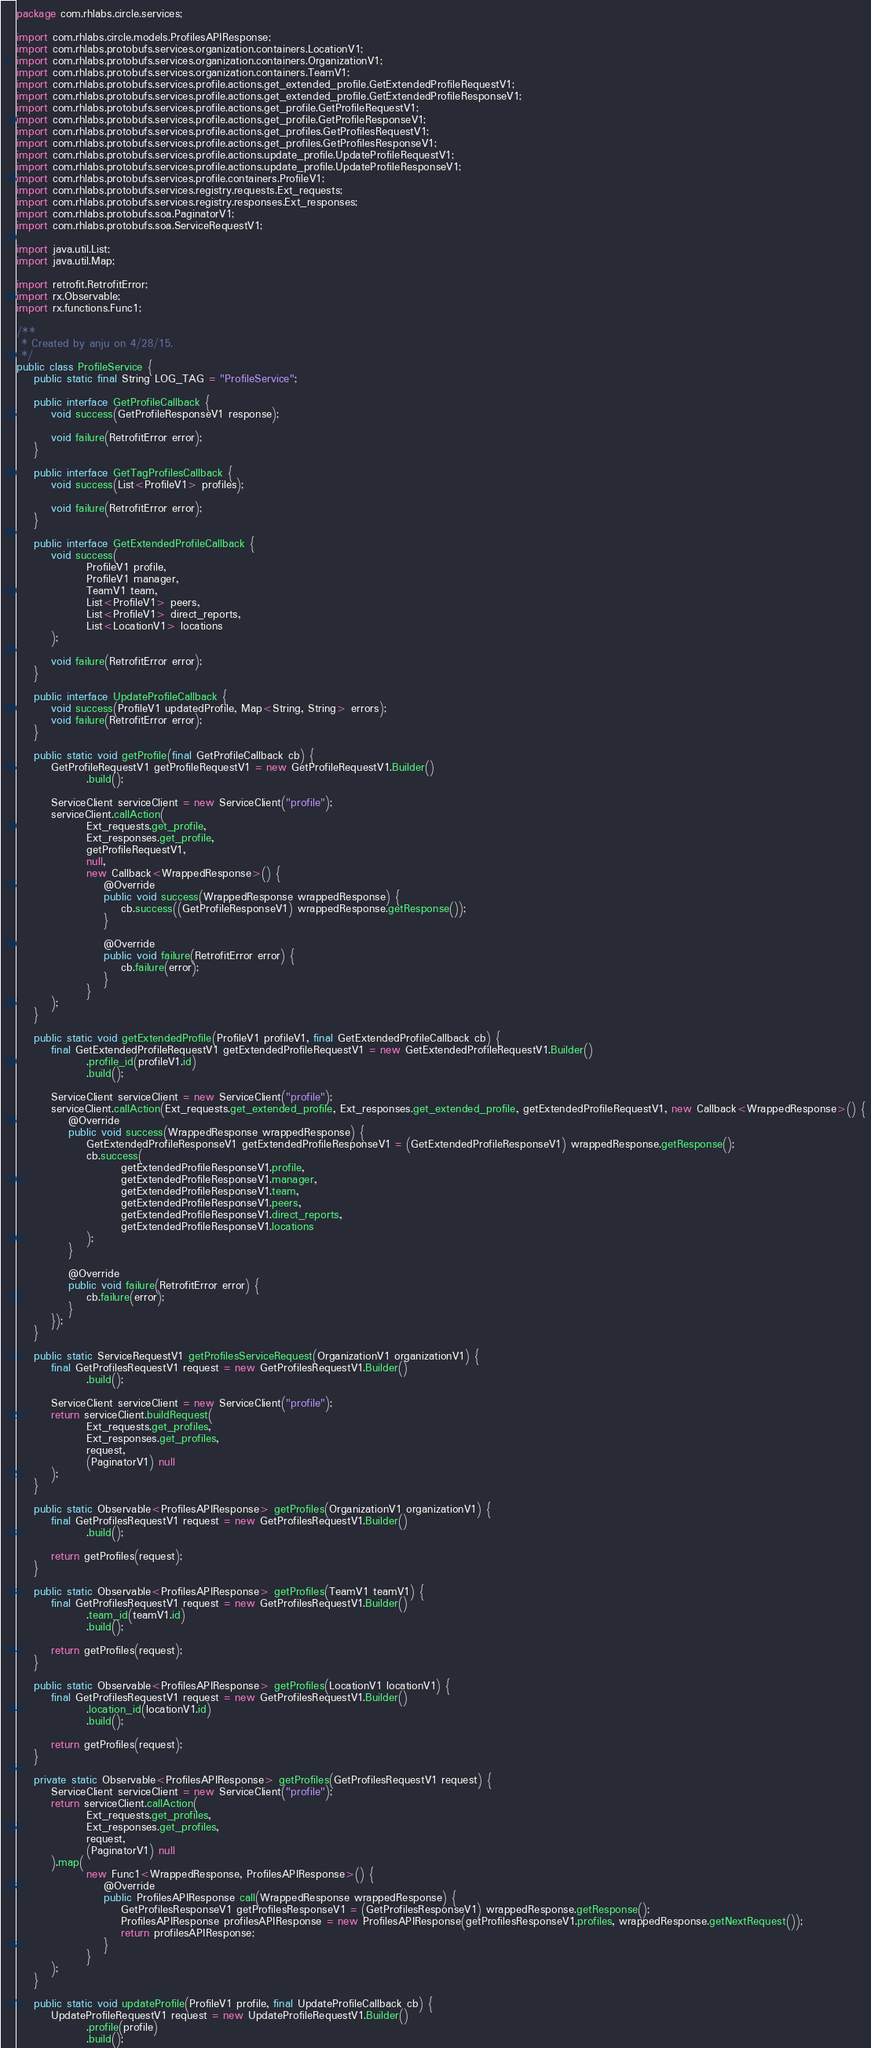<code> <loc_0><loc_0><loc_500><loc_500><_Java_>package com.rhlabs.circle.services;

import com.rhlabs.circle.models.ProfilesAPIResponse;
import com.rhlabs.protobufs.services.organization.containers.LocationV1;
import com.rhlabs.protobufs.services.organization.containers.OrganizationV1;
import com.rhlabs.protobufs.services.organization.containers.TeamV1;
import com.rhlabs.protobufs.services.profile.actions.get_extended_profile.GetExtendedProfileRequestV1;
import com.rhlabs.protobufs.services.profile.actions.get_extended_profile.GetExtendedProfileResponseV1;
import com.rhlabs.protobufs.services.profile.actions.get_profile.GetProfileRequestV1;
import com.rhlabs.protobufs.services.profile.actions.get_profile.GetProfileResponseV1;
import com.rhlabs.protobufs.services.profile.actions.get_profiles.GetProfilesRequestV1;
import com.rhlabs.protobufs.services.profile.actions.get_profiles.GetProfilesResponseV1;
import com.rhlabs.protobufs.services.profile.actions.update_profile.UpdateProfileRequestV1;
import com.rhlabs.protobufs.services.profile.actions.update_profile.UpdateProfileResponseV1;
import com.rhlabs.protobufs.services.profile.containers.ProfileV1;
import com.rhlabs.protobufs.services.registry.requests.Ext_requests;
import com.rhlabs.protobufs.services.registry.responses.Ext_responses;
import com.rhlabs.protobufs.soa.PaginatorV1;
import com.rhlabs.protobufs.soa.ServiceRequestV1;

import java.util.List;
import java.util.Map;

import retrofit.RetrofitError;
import rx.Observable;
import rx.functions.Func1;

/**
 * Created by anju on 4/28/15.
 */
public class ProfileService {
    public static final String LOG_TAG = "ProfileService";

    public interface GetProfileCallback {
        void success(GetProfileResponseV1 response);

        void failure(RetrofitError error);
    }

    public interface GetTagProfilesCallback {
        void success(List<ProfileV1> profiles);

        void failure(RetrofitError error);
    }

    public interface GetExtendedProfileCallback {
        void success(
                ProfileV1 profile,
                ProfileV1 manager,
                TeamV1 team,
                List<ProfileV1> peers,
                List<ProfileV1> direct_reports,
                List<LocationV1> locations
        );

        void failure(RetrofitError error);
    }

    public interface UpdateProfileCallback {
        void success(ProfileV1 updatedProfile, Map<String, String> errors);
        void failure(RetrofitError error);
    }

    public static void getProfile(final GetProfileCallback cb) {
        GetProfileRequestV1 getProfileRequestV1 = new GetProfileRequestV1.Builder()
                .build();

        ServiceClient serviceClient = new ServiceClient("profile");
        serviceClient.callAction(
                Ext_requests.get_profile,
                Ext_responses.get_profile,
                getProfileRequestV1,
                null,
                new Callback<WrappedResponse>() {
                    @Override
                    public void success(WrappedResponse wrappedResponse) {
                        cb.success((GetProfileResponseV1) wrappedResponse.getResponse());
                    }

                    @Override
                    public void failure(RetrofitError error) {
                        cb.failure(error);
                    }
                }
        );
    }

    public static void getExtendedProfile(ProfileV1 profileV1, final GetExtendedProfileCallback cb) {
        final GetExtendedProfileRequestV1 getExtendedProfileRequestV1 = new GetExtendedProfileRequestV1.Builder()
                .profile_id(profileV1.id)
                .build();

        ServiceClient serviceClient = new ServiceClient("profile");
        serviceClient.callAction(Ext_requests.get_extended_profile, Ext_responses.get_extended_profile, getExtendedProfileRequestV1, new Callback<WrappedResponse>() {
            @Override
            public void success(WrappedResponse wrappedResponse) {
                GetExtendedProfileResponseV1 getExtendedProfileResponseV1 = (GetExtendedProfileResponseV1) wrappedResponse.getResponse();
                cb.success(
                        getExtendedProfileResponseV1.profile,
                        getExtendedProfileResponseV1.manager,
                        getExtendedProfileResponseV1.team,
                        getExtendedProfileResponseV1.peers,
                        getExtendedProfileResponseV1.direct_reports,
                        getExtendedProfileResponseV1.locations
                );
            }

            @Override
            public void failure(RetrofitError error) {
                cb.failure(error);
            }
        });
    }

    public static ServiceRequestV1 getProfilesServiceRequest(OrganizationV1 organizationV1) {
        final GetProfilesRequestV1 request = new GetProfilesRequestV1.Builder()
                .build();

        ServiceClient serviceClient = new ServiceClient("profile");
        return serviceClient.buildRequest(
                Ext_requests.get_profiles,
                Ext_responses.get_profiles,
                request,
                (PaginatorV1) null
        );
    }

    public static Observable<ProfilesAPIResponse> getProfiles(OrganizationV1 organizationV1) {
        final GetProfilesRequestV1 request = new GetProfilesRequestV1.Builder()
                .build();

        return getProfiles(request);
    }

    public static Observable<ProfilesAPIResponse> getProfiles(TeamV1 teamV1) {
        final GetProfilesRequestV1 request = new GetProfilesRequestV1.Builder()
                .team_id(teamV1.id)
                .build();

        return getProfiles(request);
    }

    public static Observable<ProfilesAPIResponse> getProfiles(LocationV1 locationV1) {
        final GetProfilesRequestV1 request = new GetProfilesRequestV1.Builder()
                .location_id(locationV1.id)
                .build();

        return getProfiles(request);
    }

    private static Observable<ProfilesAPIResponse> getProfiles(GetProfilesRequestV1 request) {
        ServiceClient serviceClient = new ServiceClient("profile");
        return serviceClient.callAction(
                Ext_requests.get_profiles,
                Ext_responses.get_profiles,
                request,
                (PaginatorV1) null
        ).map(
                new Func1<WrappedResponse, ProfilesAPIResponse>() {
                    @Override
                    public ProfilesAPIResponse call(WrappedResponse wrappedResponse) {
                        GetProfilesResponseV1 getProfilesResponseV1 = (GetProfilesResponseV1) wrappedResponse.getResponse();
                        ProfilesAPIResponse profilesAPIResponse = new ProfilesAPIResponse(getProfilesResponseV1.profiles, wrappedResponse.getNextRequest());
                        return profilesAPIResponse;
                    }
                }
        );
    }

    public static void updateProfile(ProfileV1 profile, final UpdateProfileCallback cb) {
        UpdateProfileRequestV1 request = new UpdateProfileRequestV1.Builder()
                .profile(profile)
                .build();
</code> 